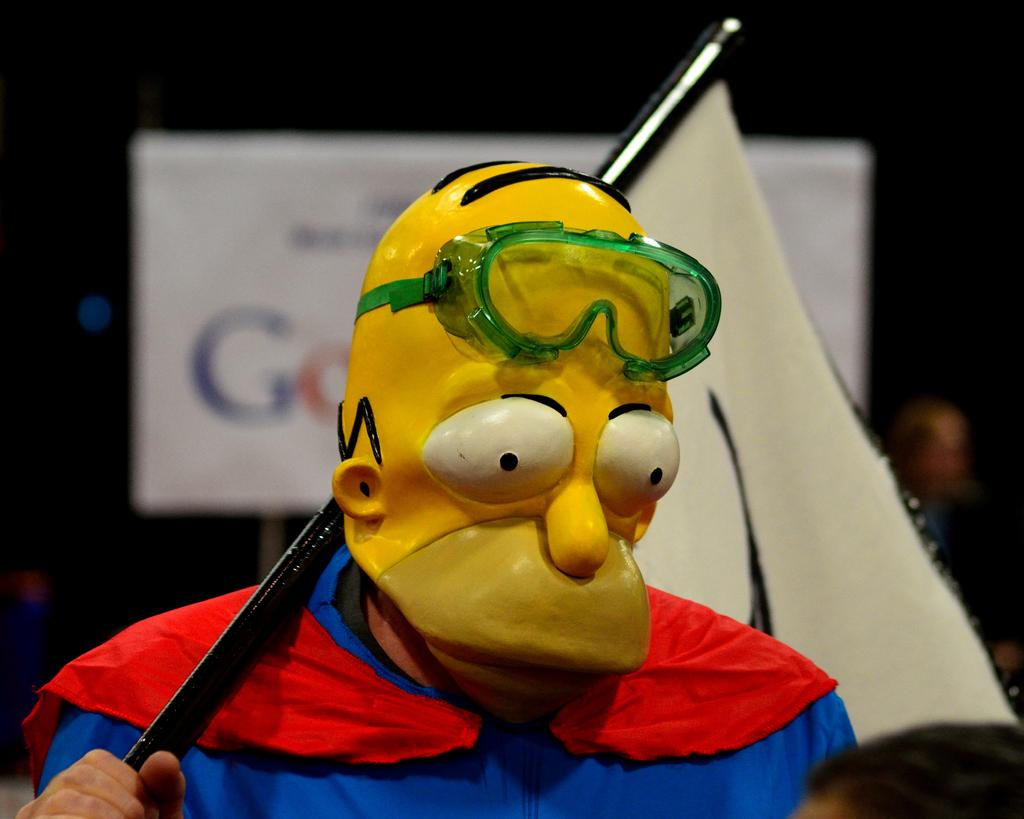Who or what is present in the image? There is a person in the image. What is the person wearing? The person is wearing a mask. What is the person holding? The person is holding a flag. Can you describe the background of the image? The background appears blurry. What else can be seen in the background? There is a banner in the background. What type of pie is being served at the zoo in the image? There is no pie or zoo present in the image. Can you describe the arch in the image? There is no arch present in the image. 